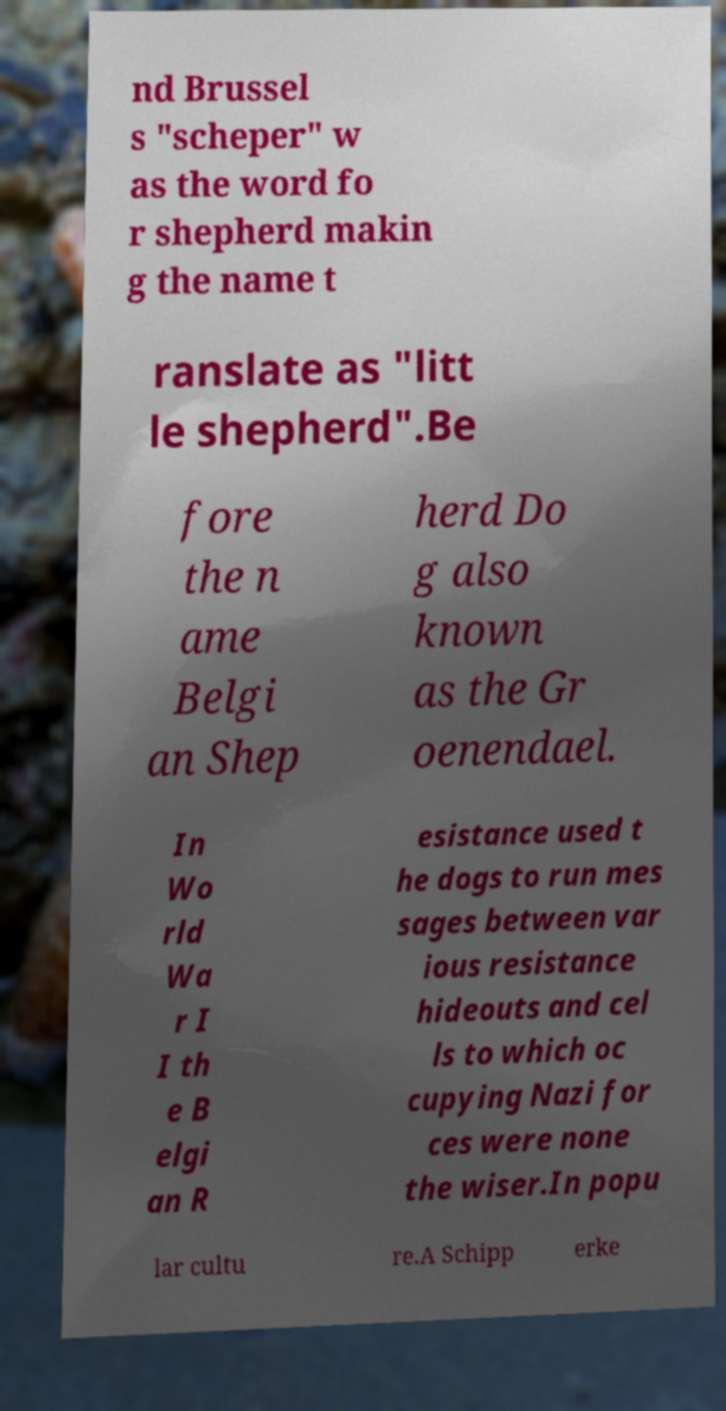Can you read and provide the text displayed in the image?This photo seems to have some interesting text. Can you extract and type it out for me? nd Brussel s "scheper" w as the word fo r shepherd makin g the name t ranslate as "litt le shepherd".Be fore the n ame Belgi an Shep herd Do g also known as the Gr oenendael. In Wo rld Wa r I I th e B elgi an R esistance used t he dogs to run mes sages between var ious resistance hideouts and cel ls to which oc cupying Nazi for ces were none the wiser.In popu lar cultu re.A Schipp erke 